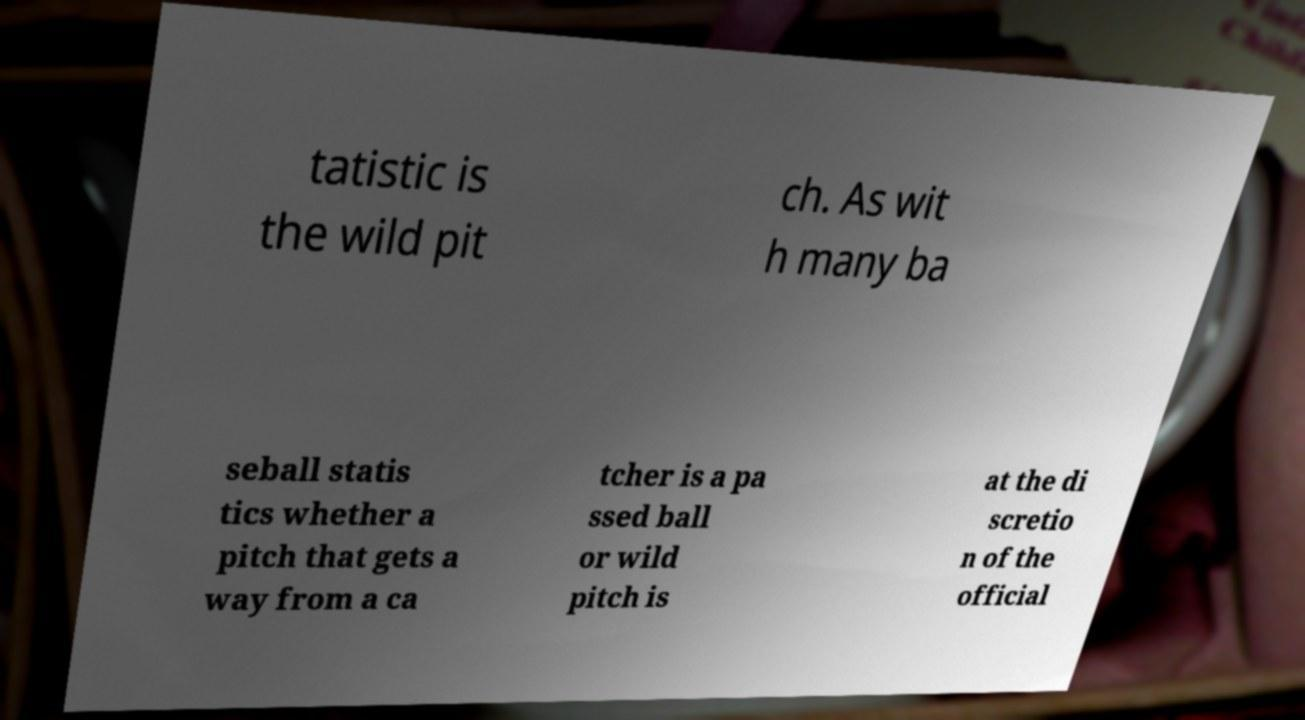Can you accurately transcribe the text from the provided image for me? tatistic is the wild pit ch. As wit h many ba seball statis tics whether a pitch that gets a way from a ca tcher is a pa ssed ball or wild pitch is at the di scretio n of the official 